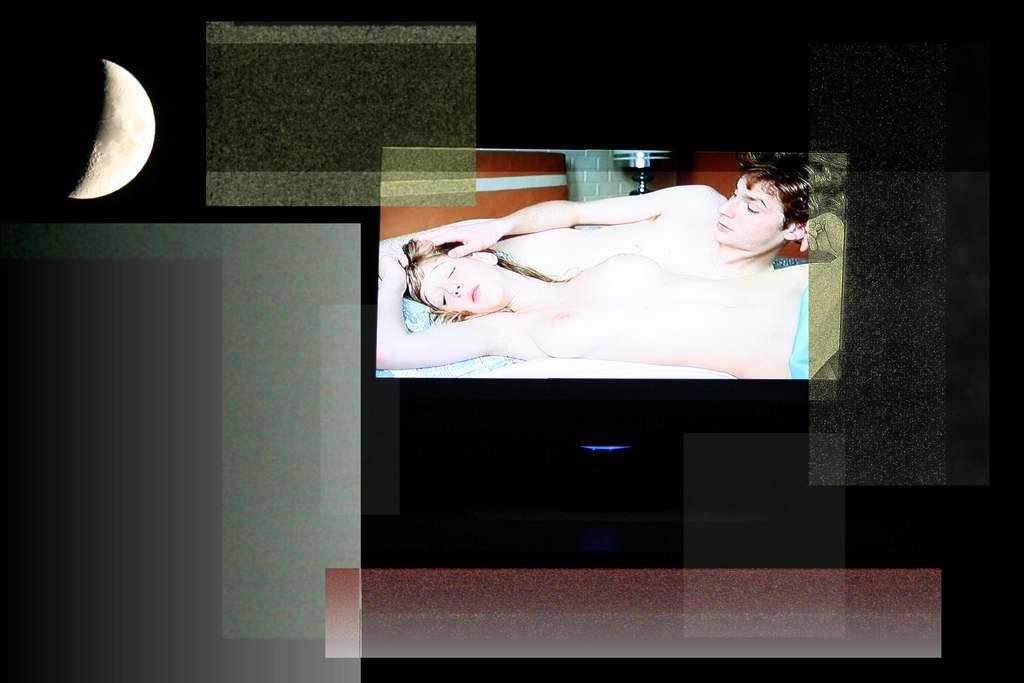How many people are in the image? There are two persons lying on the bed in the image. What can be seen in the sky in the image? There is a moon visible in the image. Can you describe the background of the image? The background of the image is blurred. What type of rake is being used to clean the lamp in the image? There is no rake or lamp present in the image. 